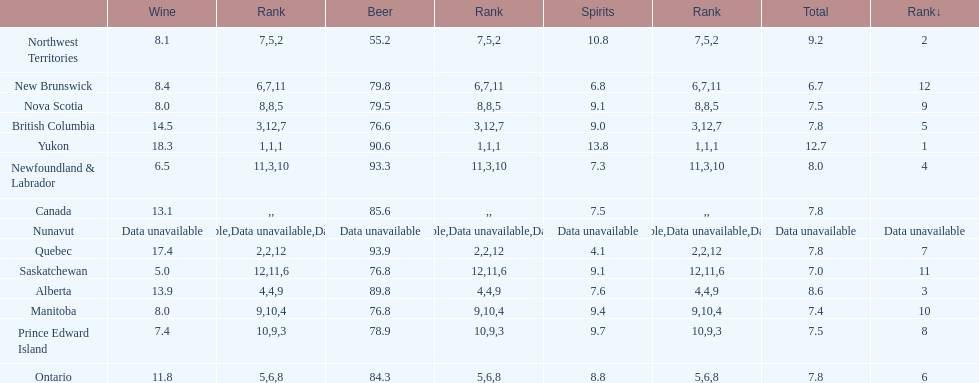Which province consumes the least amount of spirits? Quebec. 